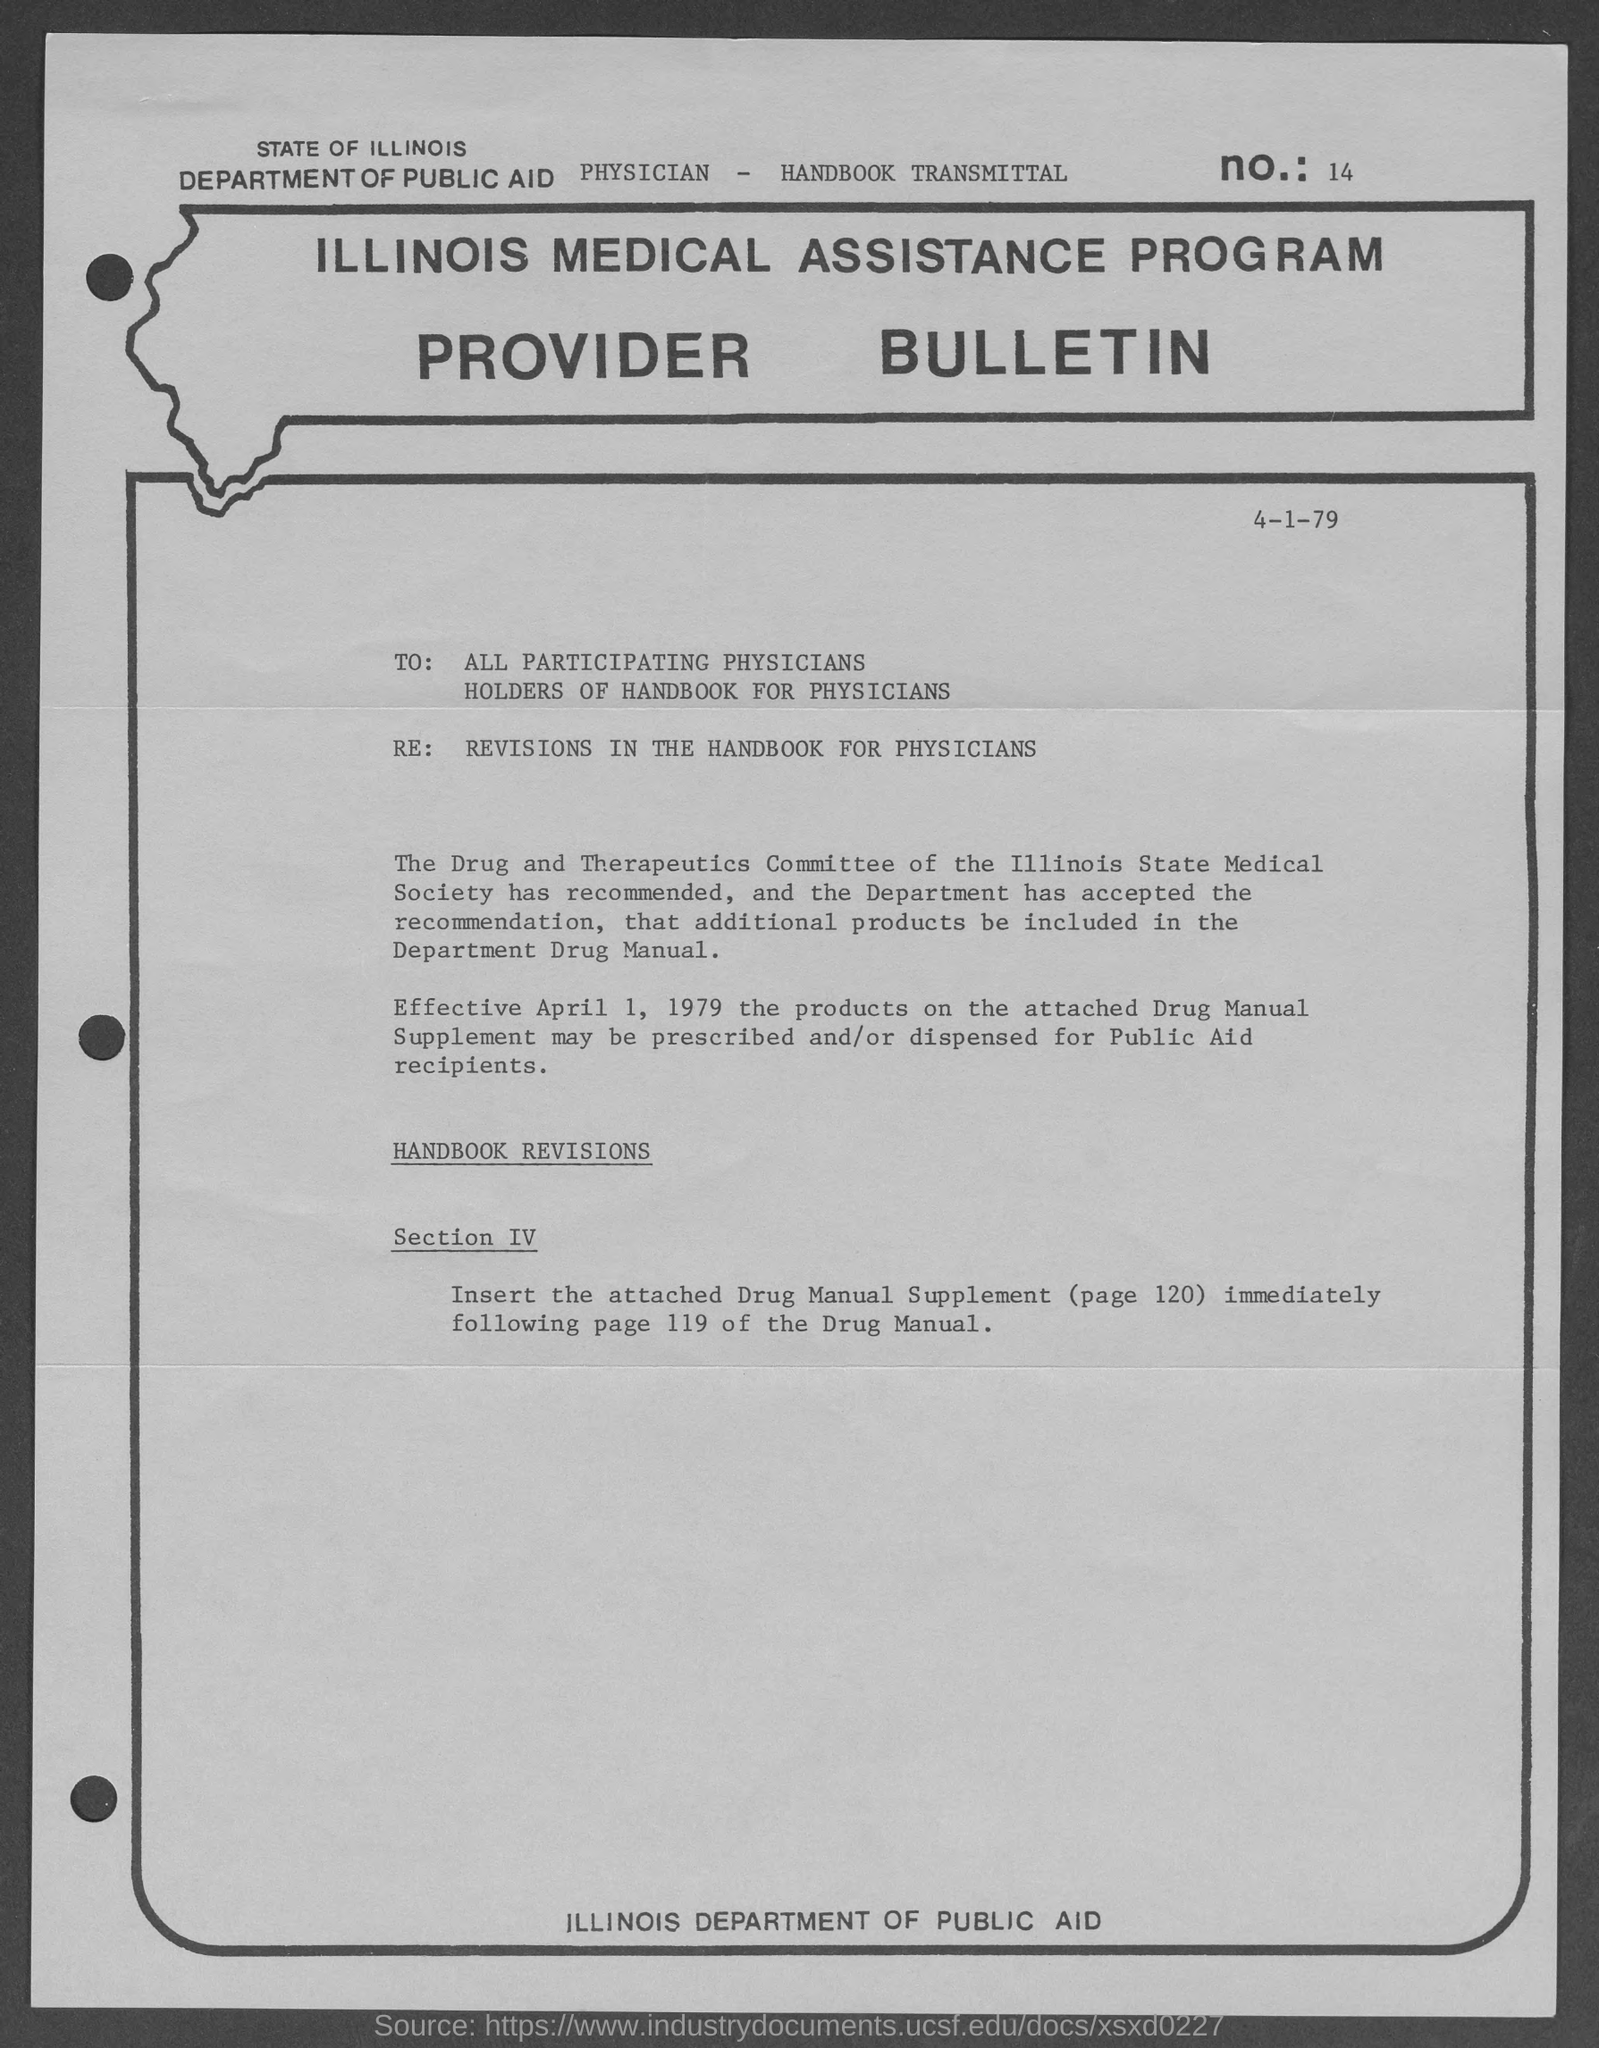Draw attention to some important aspects in this diagram. The date on the document is 4-1-79. 